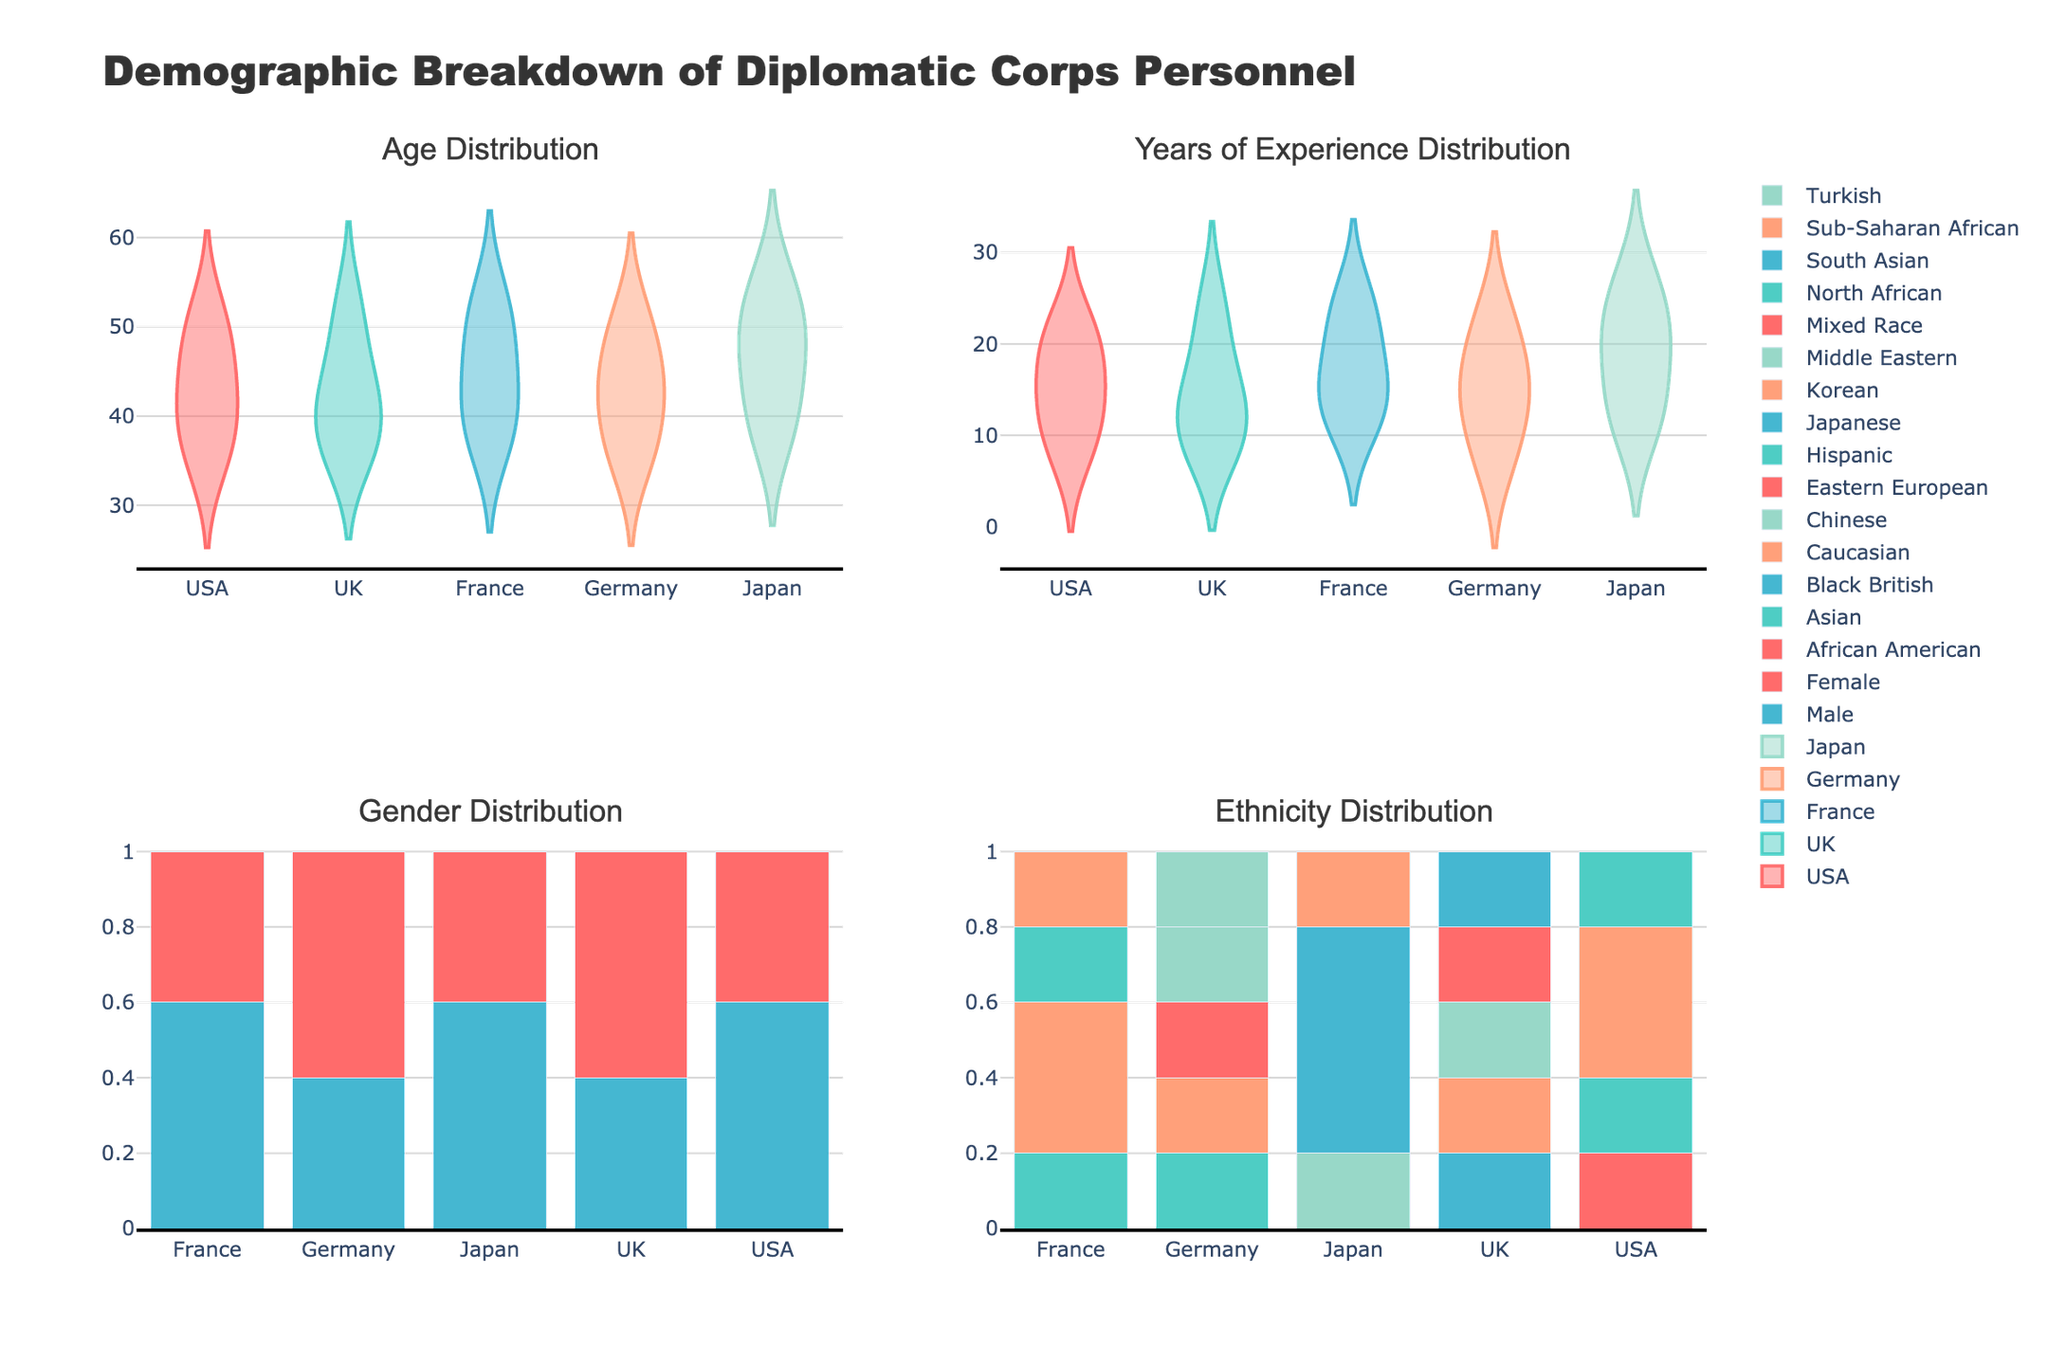What is the title of the figure? The title of the figure is displayed at the top, which helps to understand the main subject of the visualization.
Answer: Demographic Breakdown of Diplomatic Corps Personnel Which gender has a higher representation in the USA diplomatic corps? The lower-left subplot shows the percentage of males and females in each country. By looking at the USA, it shows that males have a higher value in the bar plot.
Answer: Male Between France and Germany, which country has a higher median age of their diplomatic corps personnel? The upper-left subplot displays age distribution per country. Comparing the central tendencies of the two countries' distributions, Germany’s distribution appears to have a higher central value.
Answer: Germany What is the most represented ethnicity in the UK diplomatic corps? The lower-right subplot shows the percentage of different ethnicities. The ethnicity with the highest bar for the UK represents the most common ethnicity.
Answer: Caucasian Which country has the broadest range of years of experience? The upper-right subplot shows the distribution of years of experience. Japan has the widest spread of data points across the x-axis, indicating a broad range of experience years among its personnel.
Answer: Japan Are there more Caucasian males or females in the French diplomatic corps? The lower-right subplot combined with prior knowledge indicates the distribution by gender and ethnicity. Based on the gender distribution for France in the lower-left subplot, males seem to be more represented which implies likely more Caucasian males.
Answer: Male Which country has the smallest representation of Asian ethnicity? The lower-right subplot shows each country’s ethnic distribution by percentage. By looking at the Asian category, the country with the shortest bar for Asian ethnicity represents the smallest representation.
Answer: Germany How does the age distribution of the USA compare to that of France? The upper-left subplot each with a density plot per country. USA has a relatively concentrated age group around the early 40s while France has a more even spread from late 30s to early 50s.
Answer: USA is more concentrated in the early 40s; France is more spread out How does the experience level in the UK compare with that in Japan? The upper-right subplot shows the violin plots for years of experience. Japan's plot shows a wide distribution and longer median indicating higher experience levels compared to the UK.
Answer: Japan has a higher experience level Which country has the most balanced gender distribution? The lower-left subplot comparably shows the percentage of males and females in each country. The country with bar plots of nearly equal height for males and females suggests a balanced gender distribution.
Answer: Germany 